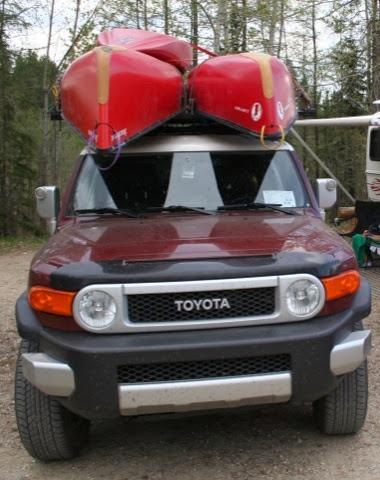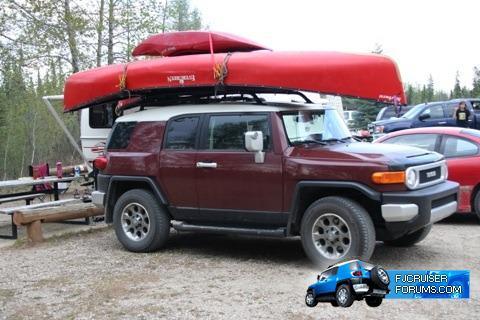The first image is the image on the left, the second image is the image on the right. Examine the images to the left and right. Is the description "Multiple boats are attached to the top of no less than one car" accurate? Answer yes or no. Yes. The first image is the image on the left, the second image is the image on the right. Evaluate the accuracy of this statement regarding the images: "At least one image shows a dark red SUV with multiple canoes on top.". Is it true? Answer yes or no. Yes. 